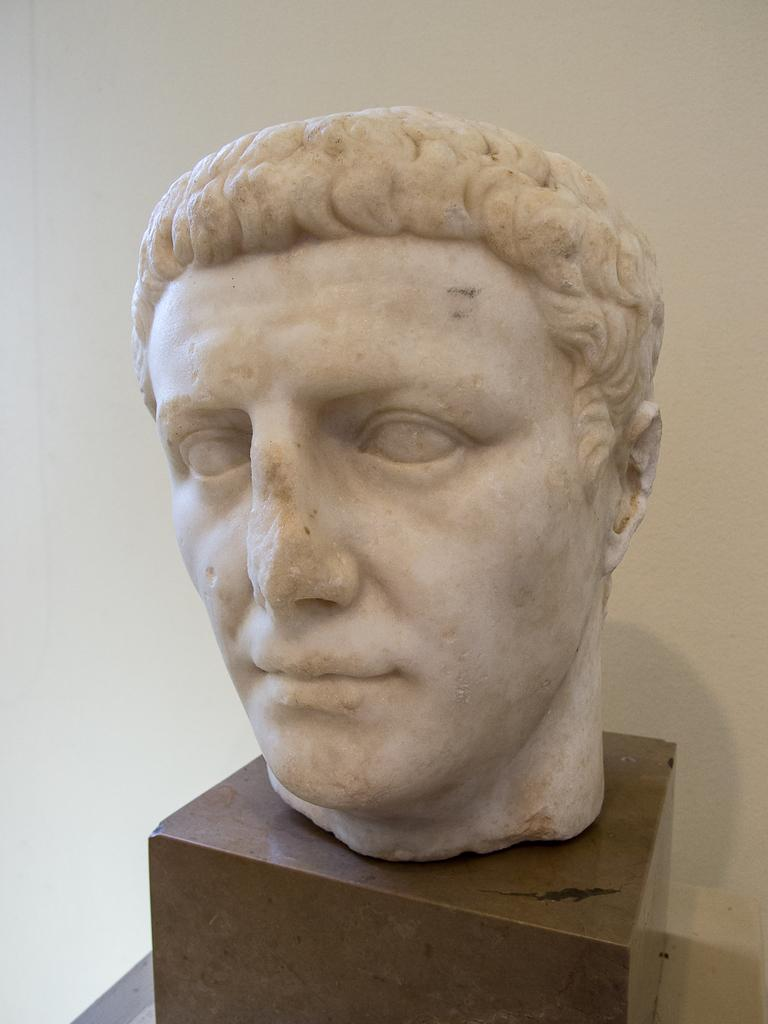What is the main subject of the image? There is a sculpture in the image. How is the sculpture positioned in the image? The sculpture is placed on a stand. What can be seen in the background of the image? There is a wall in the background of the image. What type of humor can be seen in the writing on the sculpture? There is no writing present on the sculpture, so it is not possible to determine if there is any humor in the writing. 